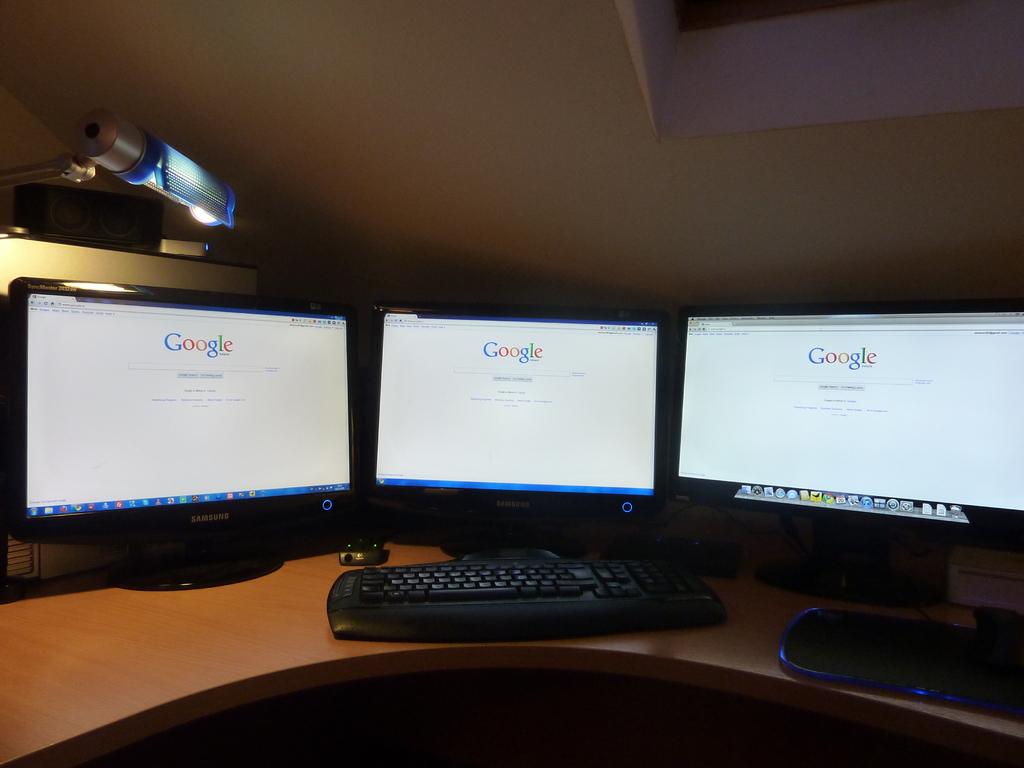What is the search engine that is shown?
Ensure brevity in your answer.  Google. What is the brand of monitor on the far left?
Provide a short and direct response. Samsung. 